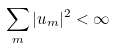<formula> <loc_0><loc_0><loc_500><loc_500>\sum _ { m } | u _ { m } | ^ { 2 } < \infty</formula> 